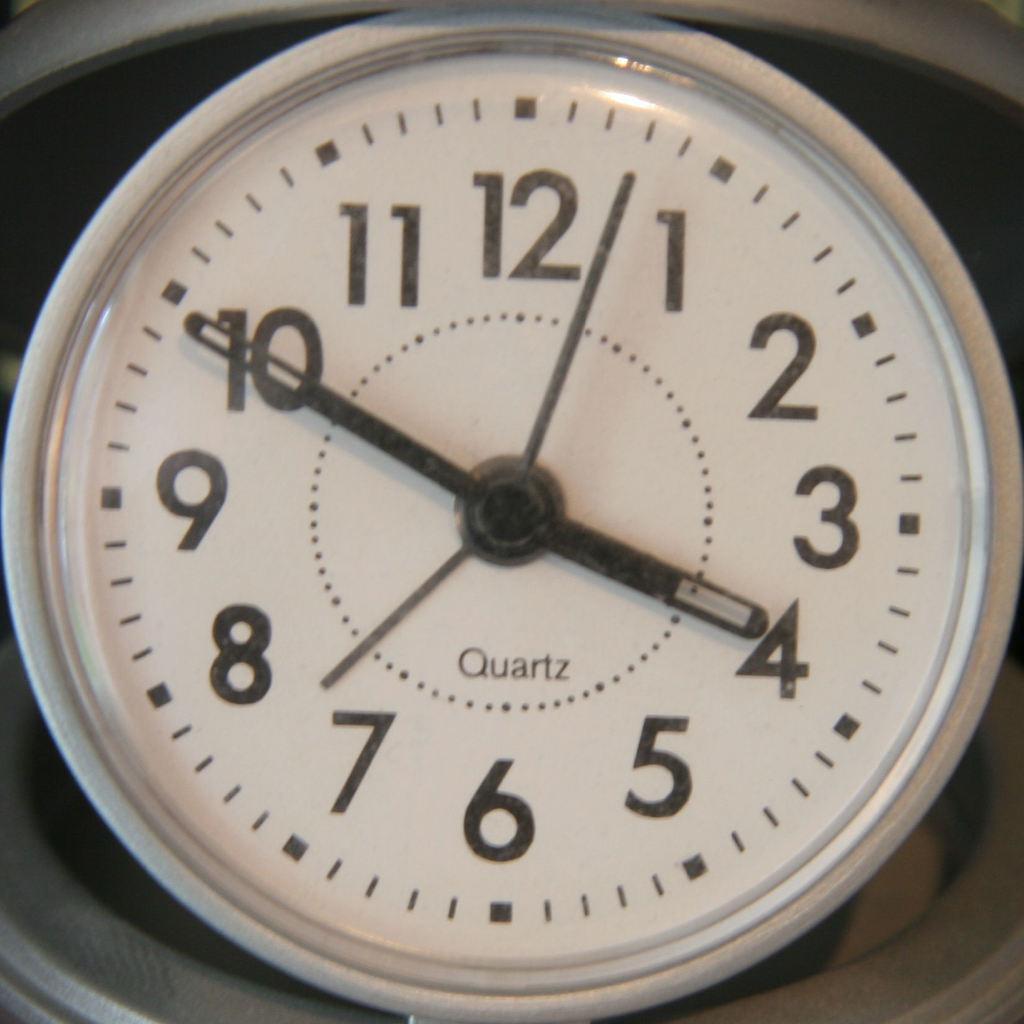<image>
Share a concise interpretation of the image provided. The clock uses a quartz movement, the time is 10 minutes before four. 